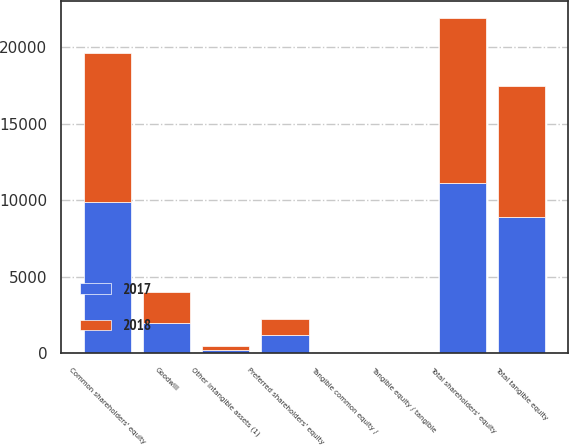Convert chart. <chart><loc_0><loc_0><loc_500><loc_500><stacked_bar_chart><ecel><fcel>Common shareholders' equity<fcel>Preferred shareholders' equity<fcel>Total shareholders' equity<fcel>Goodwill<fcel>Other intangible assets (1)<fcel>Total tangible equity<fcel>Tangible equity / tangible<fcel>Tangible common equity /<nl><fcel>2017<fcel>9899<fcel>1203<fcel>11102<fcel>1989<fcel>222<fcel>8891<fcel>8.34<fcel>7.21<nl><fcel>2018<fcel>9743<fcel>1071<fcel>10814<fcel>1993<fcel>273<fcel>8548<fcel>8.39<fcel>7.34<nl></chart> 